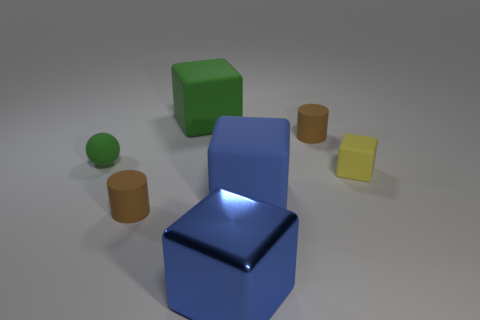Subtract 2 cubes. How many cubes are left? 2 Add 2 blue cubes. How many objects exist? 9 Subtract all cyan cubes. Subtract all cyan cylinders. How many cubes are left? 4 Subtract all cubes. How many objects are left? 3 Subtract all cyan cylinders. Subtract all tiny brown cylinders. How many objects are left? 5 Add 3 small balls. How many small balls are left? 4 Add 7 large blue rubber blocks. How many large blue rubber blocks exist? 8 Subtract 1 green blocks. How many objects are left? 6 